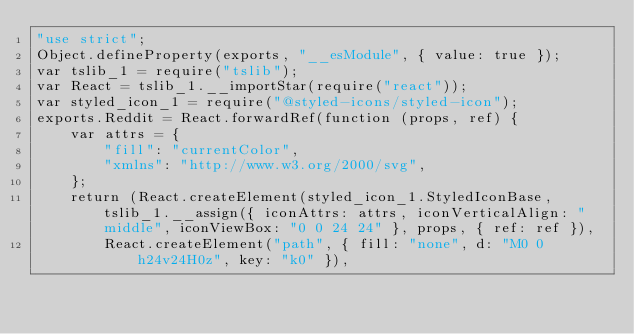Convert code to text. <code><loc_0><loc_0><loc_500><loc_500><_JavaScript_>"use strict";
Object.defineProperty(exports, "__esModule", { value: true });
var tslib_1 = require("tslib");
var React = tslib_1.__importStar(require("react"));
var styled_icon_1 = require("@styled-icons/styled-icon");
exports.Reddit = React.forwardRef(function (props, ref) {
    var attrs = {
        "fill": "currentColor",
        "xmlns": "http://www.w3.org/2000/svg",
    };
    return (React.createElement(styled_icon_1.StyledIconBase, tslib_1.__assign({ iconAttrs: attrs, iconVerticalAlign: "middle", iconViewBox: "0 0 24 24" }, props, { ref: ref }),
        React.createElement("path", { fill: "none", d: "M0 0h24v24H0z", key: "k0" }),</code> 